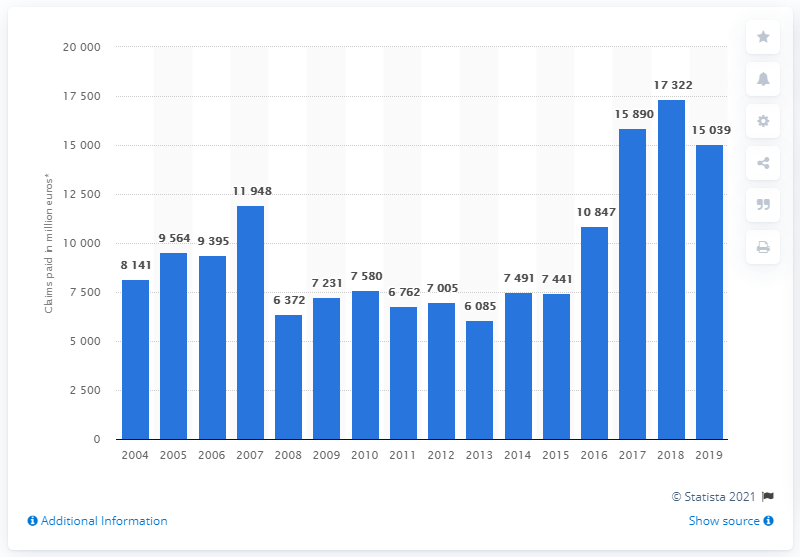Point out several critical features in this image. In 2019, property insurance companies paid a total of $150,390 in claims. 